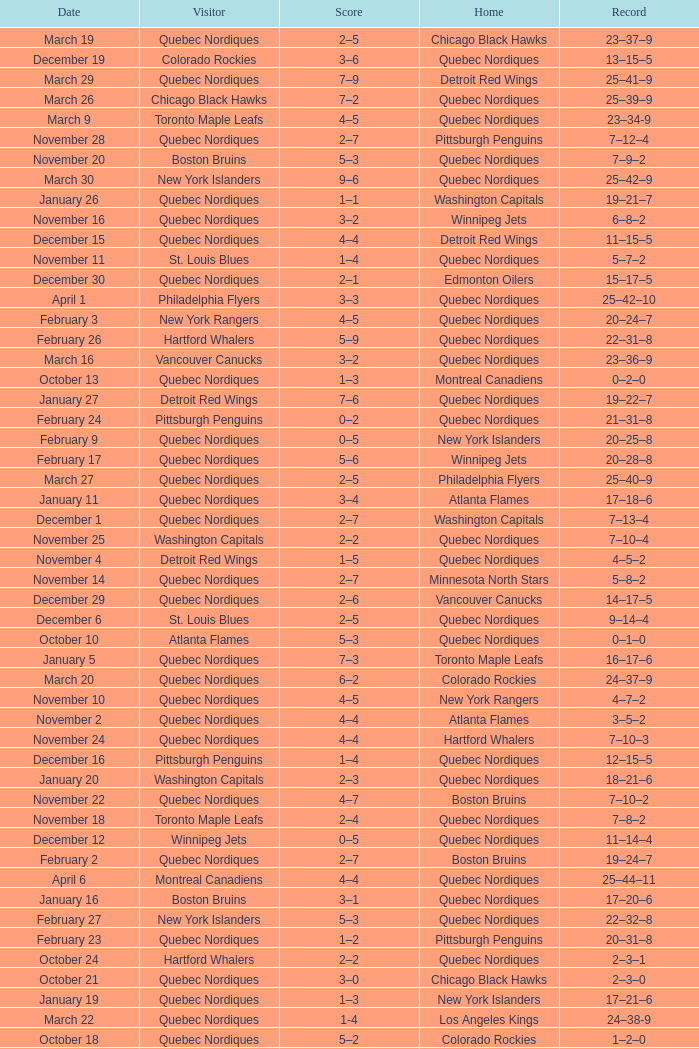Which Record has a Home of edmonton oilers, and a Score of 3–6? 1–3–0. 